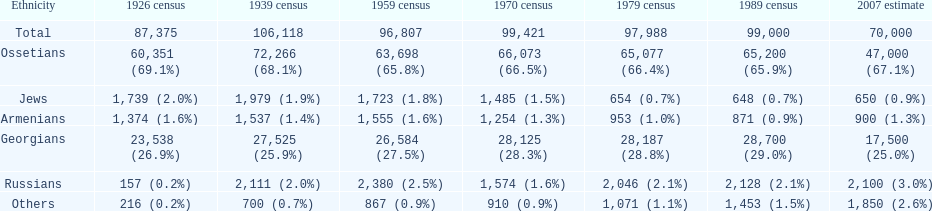Which population had the most people in 1926? Ossetians. 